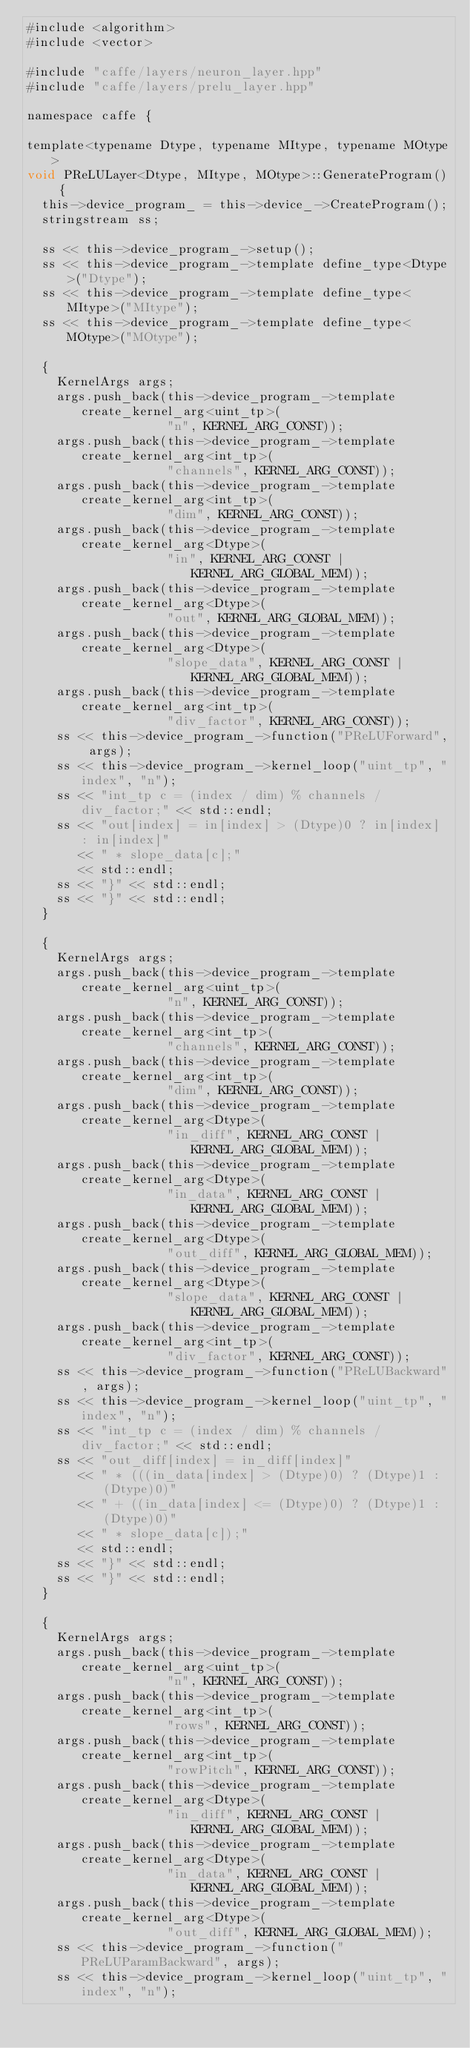<code> <loc_0><loc_0><loc_500><loc_500><_Cuda_>#include <algorithm>
#include <vector>

#include "caffe/layers/neuron_layer.hpp"
#include "caffe/layers/prelu_layer.hpp"

namespace caffe {

template<typename Dtype, typename MItype, typename MOtype>
void PReLULayer<Dtype, MItype, MOtype>::GenerateProgram() {
  this->device_program_ = this->device_->CreateProgram();
  stringstream ss;

  ss << this->device_program_->setup();
  ss << this->device_program_->template define_type<Dtype>("Dtype");
  ss << this->device_program_->template define_type<MItype>("MItype");
  ss << this->device_program_->template define_type<MOtype>("MOtype");

  {
    KernelArgs args;
    args.push_back(this->device_program_->template create_kernel_arg<uint_tp>(
                   "n", KERNEL_ARG_CONST));
    args.push_back(this->device_program_->template create_kernel_arg<int_tp>(
                   "channels", KERNEL_ARG_CONST));
    args.push_back(this->device_program_->template create_kernel_arg<int_tp>(
                   "dim", KERNEL_ARG_CONST));
    args.push_back(this->device_program_->template create_kernel_arg<Dtype>(
                   "in", KERNEL_ARG_CONST | KERNEL_ARG_GLOBAL_MEM));
    args.push_back(this->device_program_->template create_kernel_arg<Dtype>(
                   "out", KERNEL_ARG_GLOBAL_MEM));
    args.push_back(this->device_program_->template create_kernel_arg<Dtype>(
                   "slope_data", KERNEL_ARG_CONST | KERNEL_ARG_GLOBAL_MEM));
    args.push_back(this->device_program_->template create_kernel_arg<int_tp>(
                   "div_factor", KERNEL_ARG_CONST));
    ss << this->device_program_->function("PReLUForward", args);
    ss << this->device_program_->kernel_loop("uint_tp", "index", "n");
    ss << "int_tp c = (index / dim) % channels / div_factor;" << std::endl;
    ss << "out[index] = in[index] > (Dtype)0 ? in[index] : in[index]"
       << " * slope_data[c];"
       << std::endl;
    ss << "}" << std::endl;
    ss << "}" << std::endl;
  }

  {
    KernelArgs args;
    args.push_back(this->device_program_->template create_kernel_arg<uint_tp>(
                   "n", KERNEL_ARG_CONST));
    args.push_back(this->device_program_->template create_kernel_arg<int_tp>(
                   "channels", KERNEL_ARG_CONST));
    args.push_back(this->device_program_->template create_kernel_arg<int_tp>(
                   "dim", KERNEL_ARG_CONST));
    args.push_back(this->device_program_->template create_kernel_arg<Dtype>(
                   "in_diff", KERNEL_ARG_CONST | KERNEL_ARG_GLOBAL_MEM));
    args.push_back(this->device_program_->template create_kernel_arg<Dtype>(
                   "in_data", KERNEL_ARG_CONST | KERNEL_ARG_GLOBAL_MEM));
    args.push_back(this->device_program_->template create_kernel_arg<Dtype>(
                   "out_diff", KERNEL_ARG_GLOBAL_MEM));
    args.push_back(this->device_program_->template create_kernel_arg<Dtype>(
                   "slope_data", KERNEL_ARG_CONST | KERNEL_ARG_GLOBAL_MEM));
    args.push_back(this->device_program_->template create_kernel_arg<int_tp>(
                   "div_factor", KERNEL_ARG_CONST));
    ss << this->device_program_->function("PReLUBackward", args);
    ss << this->device_program_->kernel_loop("uint_tp", "index", "n");
    ss << "int_tp c = (index / dim) % channels / div_factor;" << std::endl;
    ss << "out_diff[index] = in_diff[index]"
       << " * (((in_data[index] > (Dtype)0) ? (Dtype)1 : (Dtype)0)"
       << " + ((in_data[index] <= (Dtype)0) ? (Dtype)1 : (Dtype)0)"
       << " * slope_data[c]);"
       << std::endl;
    ss << "}" << std::endl;
    ss << "}" << std::endl;
  }

  {
    KernelArgs args;
    args.push_back(this->device_program_->template create_kernel_arg<uint_tp>(
                   "n", KERNEL_ARG_CONST));
    args.push_back(this->device_program_->template create_kernel_arg<int_tp>(
                   "rows", KERNEL_ARG_CONST));
    args.push_back(this->device_program_->template create_kernel_arg<int_tp>(
                   "rowPitch", KERNEL_ARG_CONST));
    args.push_back(this->device_program_->template create_kernel_arg<Dtype>(
                   "in_diff", KERNEL_ARG_CONST | KERNEL_ARG_GLOBAL_MEM));
    args.push_back(this->device_program_->template create_kernel_arg<Dtype>(
                   "in_data", KERNEL_ARG_CONST | KERNEL_ARG_GLOBAL_MEM));
    args.push_back(this->device_program_->template create_kernel_arg<Dtype>(
                   "out_diff", KERNEL_ARG_GLOBAL_MEM));
    ss << this->device_program_->function("PReLUParamBackward", args);
    ss << this->device_program_->kernel_loop("uint_tp", "index", "n");</code> 